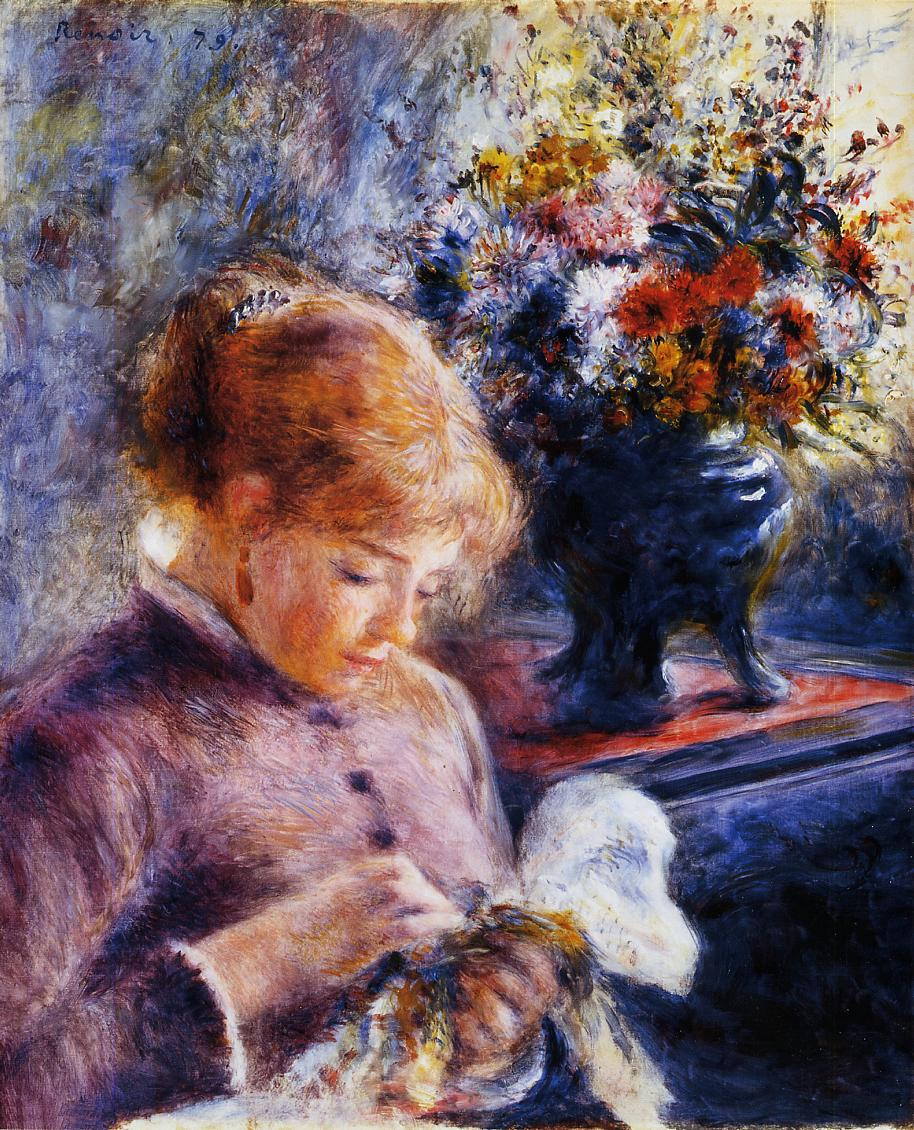If this painting were set in a magical realm, what fantastical elements might be present? In a magical realm, this painting might reveal the young woman as an enchantress, her needlework weaving spells into a shimmering tapestry of light. The flowers in the vase could exhibit their own vibrant spirits, occasionally shifting colors and softly whispering ancient secrets to one another. The background might dissolve into a picturesque window that opens to an enchanted garden, where mythical creatures like fairies and gentle forest beings flit about. Sunbeams could dance around her in a playful manner, casting a gentle glow that amplifies the magic she works with her hands. In this fantasy world, every element would pulsate with a subtle, enchanting life of its own. 